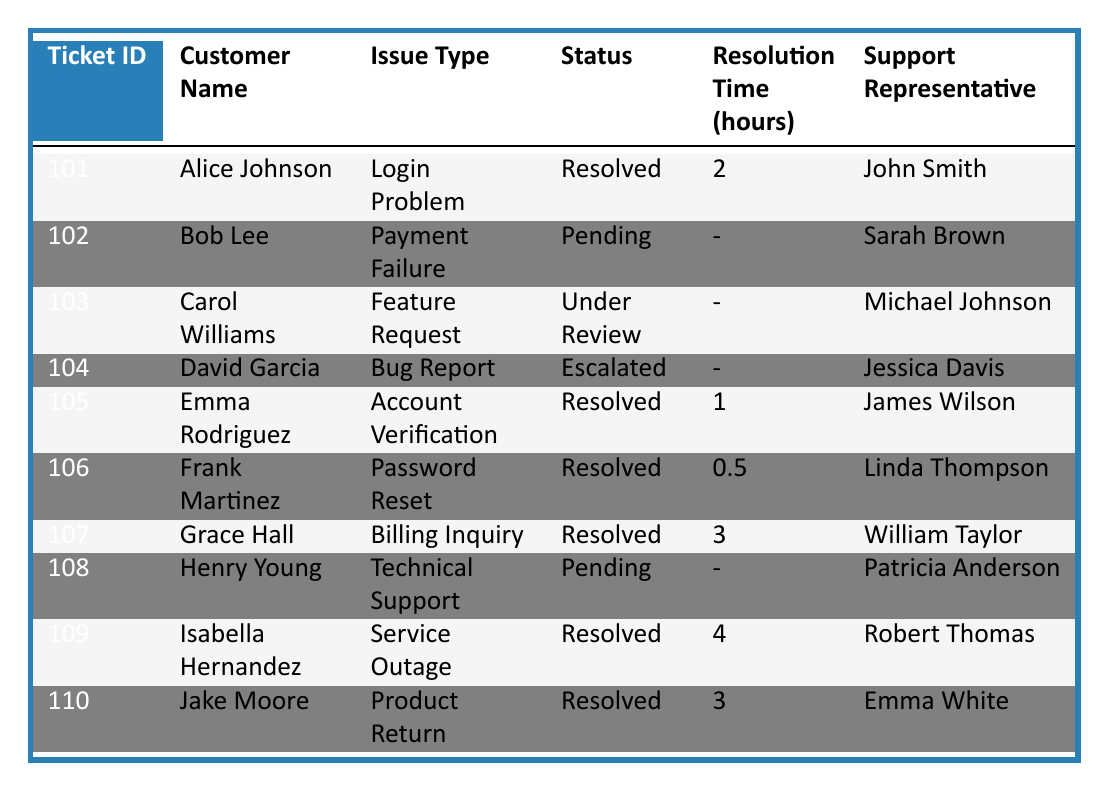What is the issue type for ticket ID 101? The ticket ID 101 corresponds to Alice Johnson, and her issue type is listed as "Login Problem" in the table.
Answer: Login Problem How many tickets are currently unresolved (Pending/Under Review/Escalated)? There are three tickets that fall under these categories: ticket 102 (Payment Failure, Pending), ticket 103 (Feature Request, Under Review), and ticket 104 (Bug Report, Escalated). Thus, the total is 3 unresolved tickets.
Answer: 3 What is the total resolution time for all resolved tickets? The resolution times for resolved tickets are as follows: 2 hours (ticket 101), 1 hour (ticket 105), 0.5 hours (ticket 106), 3 hours (ticket 107), 4 hours (ticket 109), and 3 hours (ticket 110). Adding these gives a total of 2 + 1 + 0.5 + 3 + 4 + 3 = 13.5 hours.
Answer: 13.5 hours Is the support representative for the ticket ID 104 also responsible for resolving a "Bug Report"? The support representative for ticket ID 104, which is "Bug Report" and Escalated, is Jessica Davis. There are no other entries of Jessica Davis resolving any cases in the table, hence she only handles ticket ID 104.
Answer: No What percentage of tickets are resolved compared to the total number of tickets? There are 10 tickets in total, with 6 marked as "Resolved." To find the percentage, the formula is (6 resolved / 10 total) * 100 = 60%.
Answer: 60% 